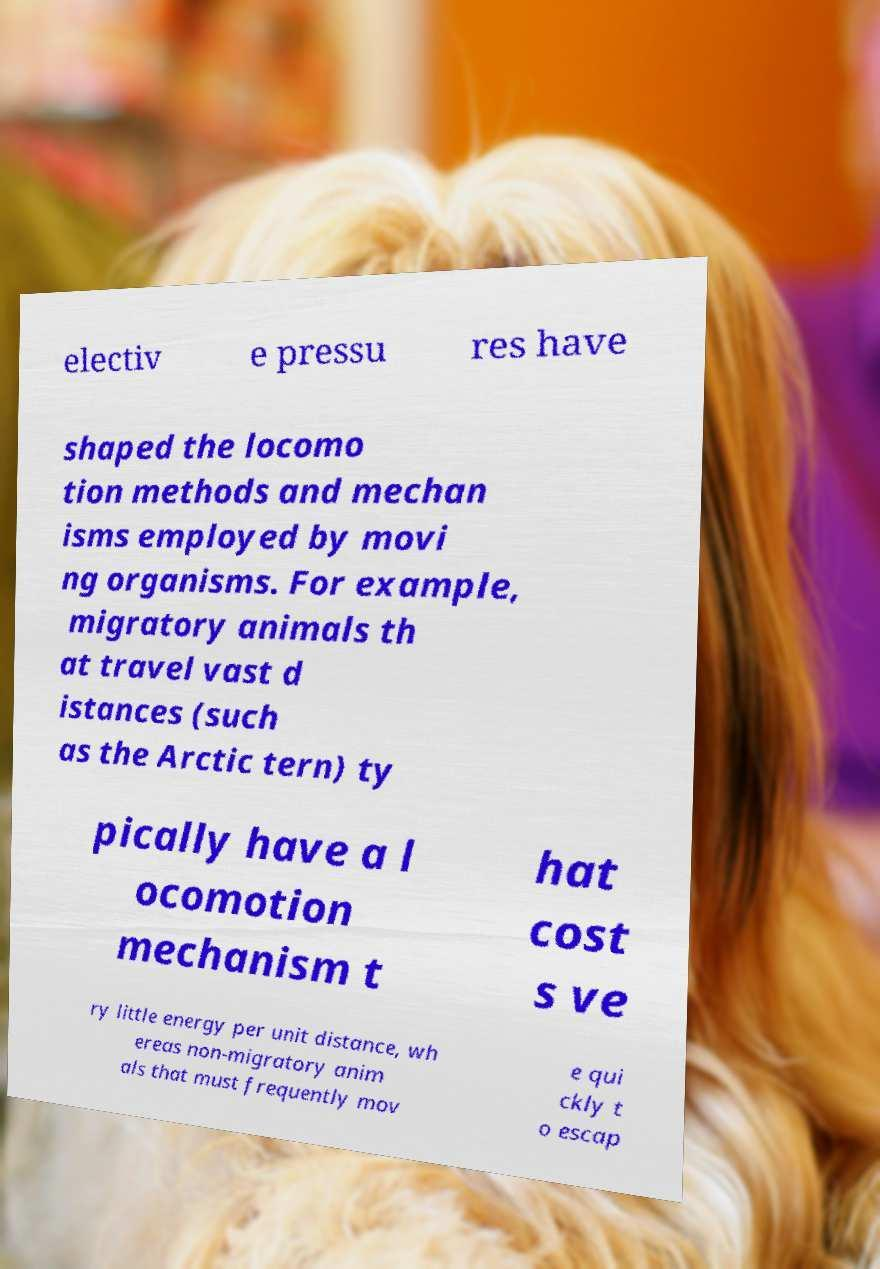What messages or text are displayed in this image? I need them in a readable, typed format. electiv e pressu res have shaped the locomo tion methods and mechan isms employed by movi ng organisms. For example, migratory animals th at travel vast d istances (such as the Arctic tern) ty pically have a l ocomotion mechanism t hat cost s ve ry little energy per unit distance, wh ereas non-migratory anim als that must frequently mov e qui ckly t o escap 